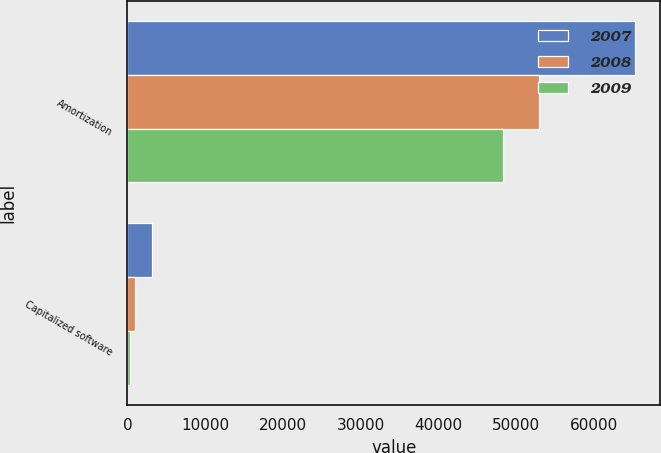Convert chart. <chart><loc_0><loc_0><loc_500><loc_500><stacked_bar_chart><ecel><fcel>Amortization<fcel>Capitalized software<nl><fcel>2007<fcel>65256<fcel>3183<nl><fcel>2008<fcel>52909<fcel>1011<nl><fcel>2009<fcel>48331<fcel>298<nl></chart> 